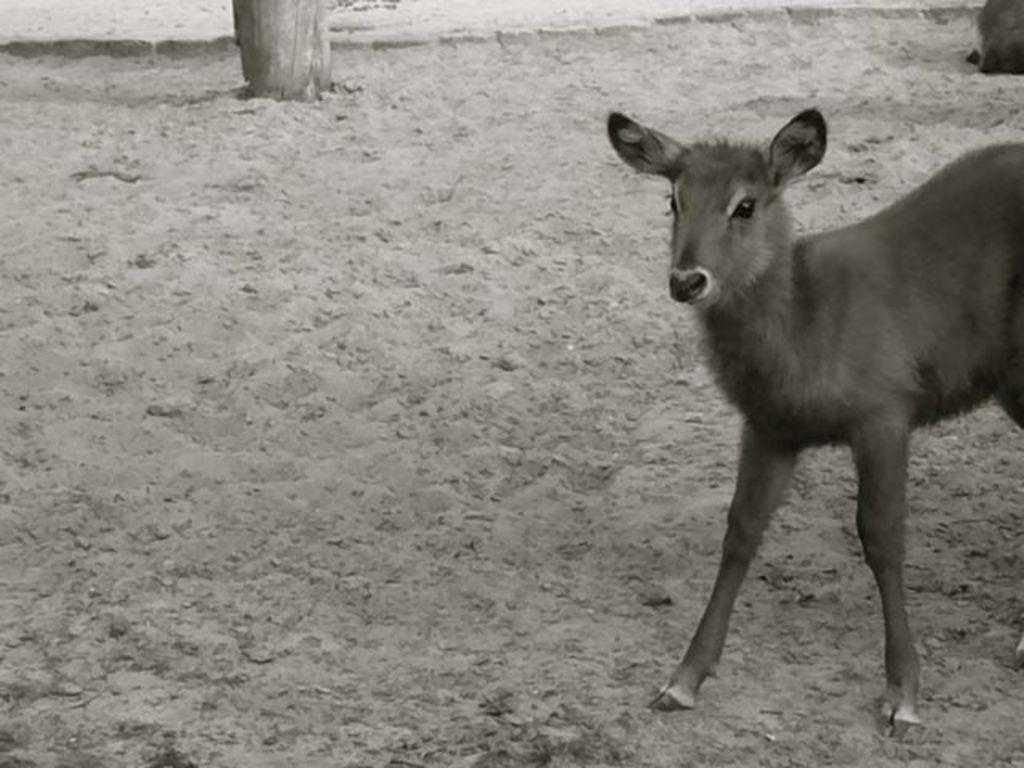What is the color scheme of the image? The image is black and white. What animal can be seen in the image? There is a baby deer in the image. On which side of the image is the baby deer standing? The baby deer is standing on the left side. What is the condition of the floor in the image? The floor is muddy. What type of cable is being used to control the movements of the baby deer in the image? There is no cable or any form of control visible in the image; the baby deer is standing on its own. 